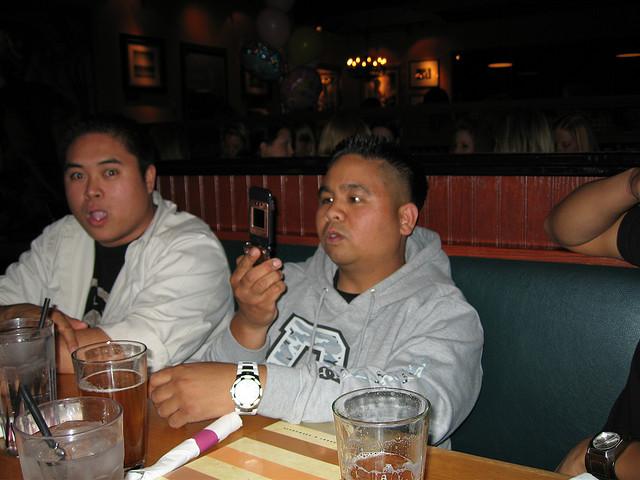What is in the glasses?
Keep it brief. Beer. Is the glass full?
Concise answer only. Yes. What color is the man's shirt?
Short answer required. Gray. Do they look like a happy couple?
Write a very short answer. No. What is everyone drinking?
Concise answer only. Beer. Are these two guys brothers?
Short answer required. Yes. What kind of glasses are on the table?
Write a very short answer. Beer. Is this a birthday party?
Short answer required. No. Is the phone likely newer than 2012?
Be succinct. No. What are these people drinking?
Answer briefly. Beer. What kind of glasses are these?
Write a very short answer. Beer. What is the expression of the person to the left?
Keep it brief. Surprise. Is there wine on the table?
Write a very short answer. No. What color is the man's jacket?
Short answer required. Gray. What kind of building was this picture taken in?
Write a very short answer. Restaurant. 